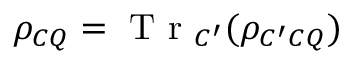<formula> <loc_0><loc_0><loc_500><loc_500>\rho _ { C Q } = T r _ { C ^ { \prime } } ( \rho _ { C ^ { \prime } C Q } )</formula> 